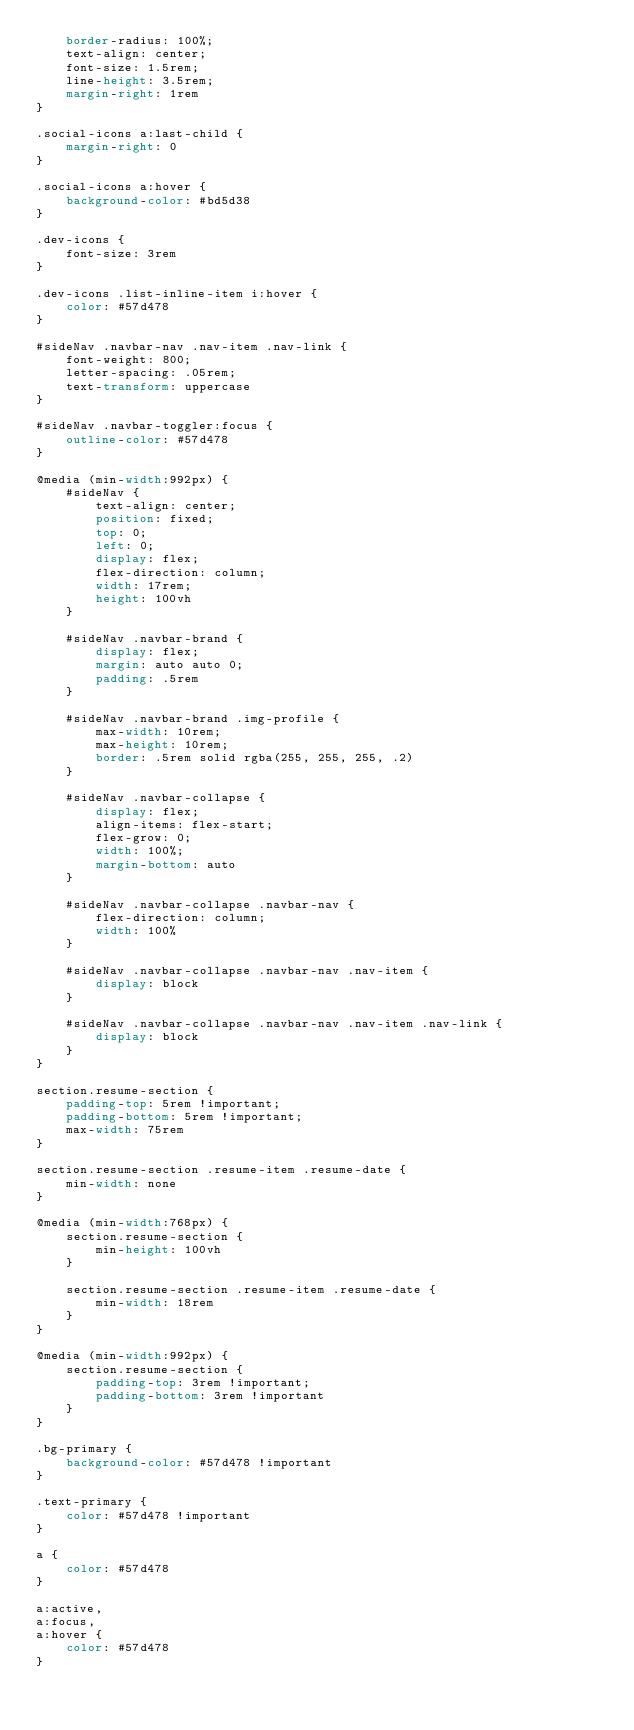<code> <loc_0><loc_0><loc_500><loc_500><_CSS_>    border-radius: 100%;
    text-align: center;
    font-size: 1.5rem;
    line-height: 3.5rem;
    margin-right: 1rem
}

.social-icons a:last-child {
    margin-right: 0
}

.social-icons a:hover {
    background-color: #bd5d38
}

.dev-icons {
    font-size: 3rem
}

.dev-icons .list-inline-item i:hover {
    color: #57d478
}

#sideNav .navbar-nav .nav-item .nav-link {
    font-weight: 800;
    letter-spacing: .05rem;
    text-transform: uppercase
}

#sideNav .navbar-toggler:focus {
    outline-color: #57d478
}

@media (min-width:992px) {
    #sideNav {
        text-align: center;
        position: fixed;
        top: 0;
        left: 0;
        display: flex;
        flex-direction: column;
        width: 17rem;
        height: 100vh
    }

    #sideNav .navbar-brand {
        display: flex;
        margin: auto auto 0;
        padding: .5rem
    }

    #sideNav .navbar-brand .img-profile {
        max-width: 10rem;
        max-height: 10rem;
        border: .5rem solid rgba(255, 255, 255, .2)
    }

    #sideNav .navbar-collapse {
        display: flex;
        align-items: flex-start;
        flex-grow: 0;
        width: 100%;
        margin-bottom: auto
    }

    #sideNav .navbar-collapse .navbar-nav {
        flex-direction: column;
        width: 100%
    }

    #sideNav .navbar-collapse .navbar-nav .nav-item {
        display: block
    }

    #sideNav .navbar-collapse .navbar-nav .nav-item .nav-link {
        display: block
    }
}

section.resume-section {
    padding-top: 5rem !important;
    padding-bottom: 5rem !important;
    max-width: 75rem
}

section.resume-section .resume-item .resume-date {
    min-width: none
}

@media (min-width:768px) {
    section.resume-section {
        min-height: 100vh
    }

    section.resume-section .resume-item .resume-date {
        min-width: 18rem
    }
}

@media (min-width:992px) {
    section.resume-section {
        padding-top: 3rem !important;
        padding-bottom: 3rem !important
    }
}

.bg-primary {
    background-color: #57d478 !important
}

.text-primary {
    color: #57d478 !important
}

a {
    color: #57d478
}

a:active,
a:focus,
a:hover {
    color: #57d478
}
</code> 